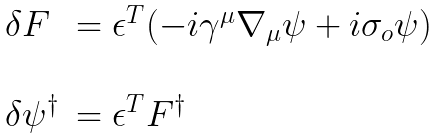Convert formula to latex. <formula><loc_0><loc_0><loc_500><loc_500>\begin{array} { l l } \delta F & = \epsilon ^ { T } ( - i \gamma ^ { \mu } \nabla _ { \mu } \psi + i \sigma _ { o } \psi ) \\ \\ \delta \psi ^ { \dagger } & = \epsilon ^ { T } F ^ { \dagger } \end{array}</formula> 